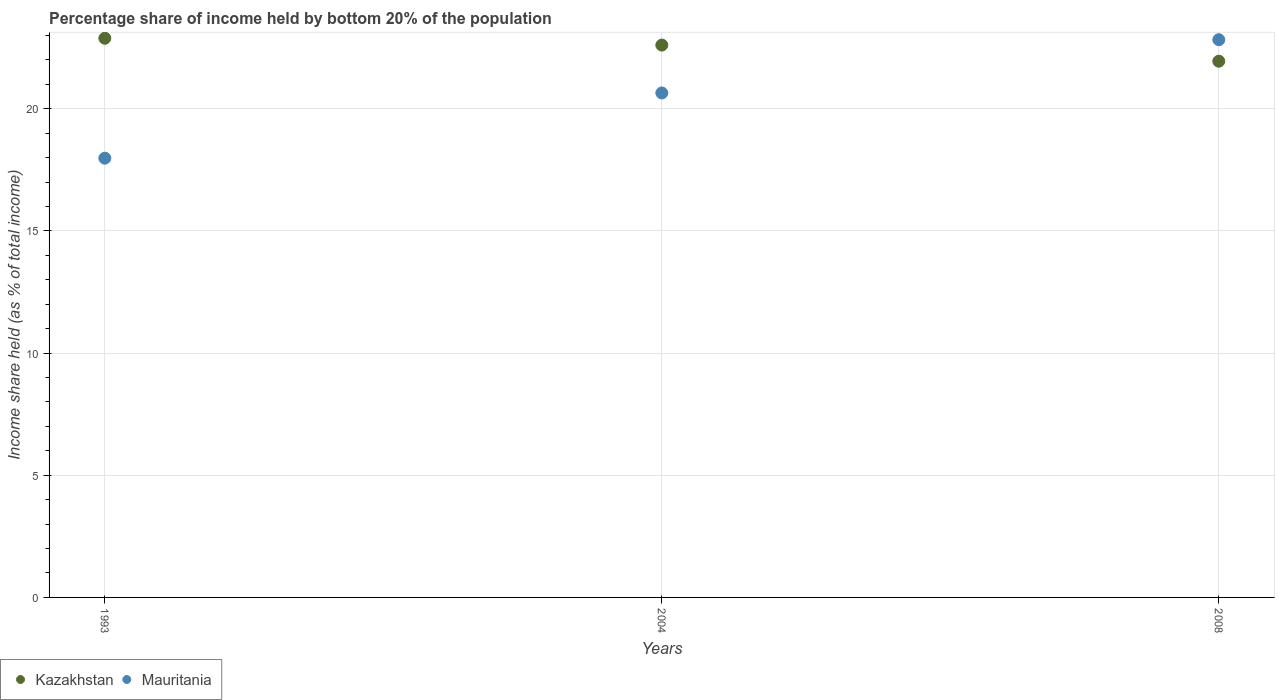Is the number of dotlines equal to the number of legend labels?
Provide a succinct answer. Yes. What is the share of income held by bottom 20% of the population in Mauritania in 2008?
Offer a terse response. 22.83. Across all years, what is the maximum share of income held by bottom 20% of the population in Mauritania?
Your answer should be compact. 22.83. Across all years, what is the minimum share of income held by bottom 20% of the population in Kazakhstan?
Offer a very short reply. 21.95. In which year was the share of income held by bottom 20% of the population in Mauritania maximum?
Give a very brief answer. 2008. What is the total share of income held by bottom 20% of the population in Kazakhstan in the graph?
Your answer should be very brief. 67.45. What is the difference between the share of income held by bottom 20% of the population in Mauritania in 2004 and that in 2008?
Provide a short and direct response. -2.18. What is the difference between the share of income held by bottom 20% of the population in Kazakhstan in 1993 and the share of income held by bottom 20% of the population in Mauritania in 2008?
Your answer should be compact. 0.06. What is the average share of income held by bottom 20% of the population in Kazakhstan per year?
Offer a terse response. 22.48. In the year 2004, what is the difference between the share of income held by bottom 20% of the population in Kazakhstan and share of income held by bottom 20% of the population in Mauritania?
Keep it short and to the point. 1.96. What is the ratio of the share of income held by bottom 20% of the population in Mauritania in 1993 to that in 2008?
Your answer should be compact. 0.79. Is the difference between the share of income held by bottom 20% of the population in Kazakhstan in 1993 and 2008 greater than the difference between the share of income held by bottom 20% of the population in Mauritania in 1993 and 2008?
Keep it short and to the point. Yes. What is the difference between the highest and the second highest share of income held by bottom 20% of the population in Kazakhstan?
Keep it short and to the point. 0.28. What is the difference between the highest and the lowest share of income held by bottom 20% of the population in Kazakhstan?
Ensure brevity in your answer.  0.94. Is the sum of the share of income held by bottom 20% of the population in Kazakhstan in 2004 and 2008 greater than the maximum share of income held by bottom 20% of the population in Mauritania across all years?
Provide a short and direct response. Yes. Does the share of income held by bottom 20% of the population in Mauritania monotonically increase over the years?
Your response must be concise. Yes. How many dotlines are there?
Keep it short and to the point. 2. Are the values on the major ticks of Y-axis written in scientific E-notation?
Your answer should be compact. No. Does the graph contain grids?
Give a very brief answer. Yes. Where does the legend appear in the graph?
Provide a short and direct response. Bottom left. How are the legend labels stacked?
Offer a terse response. Horizontal. What is the title of the graph?
Give a very brief answer. Percentage share of income held by bottom 20% of the population. What is the label or title of the Y-axis?
Offer a terse response. Income share held (as % of total income). What is the Income share held (as % of total income) of Kazakhstan in 1993?
Your answer should be compact. 22.89. What is the Income share held (as % of total income) in Mauritania in 1993?
Keep it short and to the point. 17.98. What is the Income share held (as % of total income) of Kazakhstan in 2004?
Offer a terse response. 22.61. What is the Income share held (as % of total income) in Mauritania in 2004?
Your response must be concise. 20.65. What is the Income share held (as % of total income) in Kazakhstan in 2008?
Give a very brief answer. 21.95. What is the Income share held (as % of total income) of Mauritania in 2008?
Provide a short and direct response. 22.83. Across all years, what is the maximum Income share held (as % of total income) in Kazakhstan?
Give a very brief answer. 22.89. Across all years, what is the maximum Income share held (as % of total income) in Mauritania?
Your answer should be very brief. 22.83. Across all years, what is the minimum Income share held (as % of total income) of Kazakhstan?
Provide a succinct answer. 21.95. Across all years, what is the minimum Income share held (as % of total income) of Mauritania?
Keep it short and to the point. 17.98. What is the total Income share held (as % of total income) in Kazakhstan in the graph?
Keep it short and to the point. 67.45. What is the total Income share held (as % of total income) in Mauritania in the graph?
Your answer should be very brief. 61.46. What is the difference between the Income share held (as % of total income) of Kazakhstan in 1993 and that in 2004?
Keep it short and to the point. 0.28. What is the difference between the Income share held (as % of total income) of Mauritania in 1993 and that in 2004?
Your response must be concise. -2.67. What is the difference between the Income share held (as % of total income) in Kazakhstan in 1993 and that in 2008?
Provide a short and direct response. 0.94. What is the difference between the Income share held (as % of total income) in Mauritania in 1993 and that in 2008?
Offer a terse response. -4.85. What is the difference between the Income share held (as % of total income) of Kazakhstan in 2004 and that in 2008?
Provide a short and direct response. 0.66. What is the difference between the Income share held (as % of total income) of Mauritania in 2004 and that in 2008?
Your answer should be compact. -2.18. What is the difference between the Income share held (as % of total income) of Kazakhstan in 1993 and the Income share held (as % of total income) of Mauritania in 2004?
Keep it short and to the point. 2.24. What is the difference between the Income share held (as % of total income) in Kazakhstan in 1993 and the Income share held (as % of total income) in Mauritania in 2008?
Offer a terse response. 0.06. What is the difference between the Income share held (as % of total income) in Kazakhstan in 2004 and the Income share held (as % of total income) in Mauritania in 2008?
Ensure brevity in your answer.  -0.22. What is the average Income share held (as % of total income) of Kazakhstan per year?
Your answer should be compact. 22.48. What is the average Income share held (as % of total income) of Mauritania per year?
Your response must be concise. 20.49. In the year 1993, what is the difference between the Income share held (as % of total income) in Kazakhstan and Income share held (as % of total income) in Mauritania?
Keep it short and to the point. 4.91. In the year 2004, what is the difference between the Income share held (as % of total income) of Kazakhstan and Income share held (as % of total income) of Mauritania?
Ensure brevity in your answer.  1.96. In the year 2008, what is the difference between the Income share held (as % of total income) in Kazakhstan and Income share held (as % of total income) in Mauritania?
Give a very brief answer. -0.88. What is the ratio of the Income share held (as % of total income) in Kazakhstan in 1993 to that in 2004?
Give a very brief answer. 1.01. What is the ratio of the Income share held (as % of total income) of Mauritania in 1993 to that in 2004?
Your answer should be compact. 0.87. What is the ratio of the Income share held (as % of total income) in Kazakhstan in 1993 to that in 2008?
Ensure brevity in your answer.  1.04. What is the ratio of the Income share held (as % of total income) in Mauritania in 1993 to that in 2008?
Provide a succinct answer. 0.79. What is the ratio of the Income share held (as % of total income) in Kazakhstan in 2004 to that in 2008?
Provide a succinct answer. 1.03. What is the ratio of the Income share held (as % of total income) of Mauritania in 2004 to that in 2008?
Keep it short and to the point. 0.9. What is the difference between the highest and the second highest Income share held (as % of total income) of Kazakhstan?
Give a very brief answer. 0.28. What is the difference between the highest and the second highest Income share held (as % of total income) of Mauritania?
Your response must be concise. 2.18. What is the difference between the highest and the lowest Income share held (as % of total income) of Mauritania?
Give a very brief answer. 4.85. 